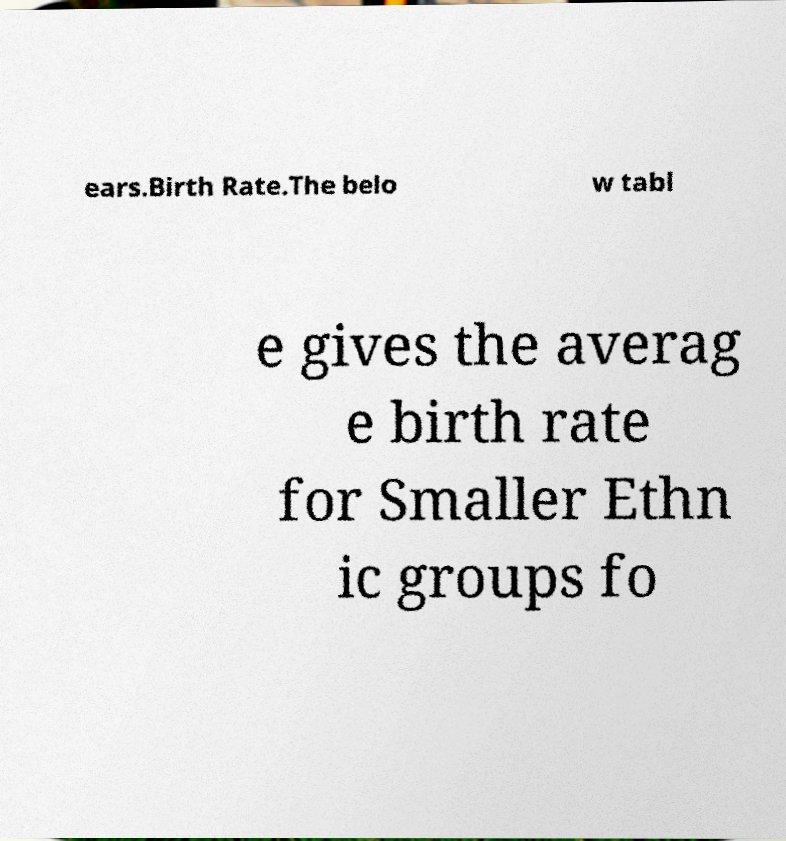Please identify and transcribe the text found in this image. ears.Birth Rate.The belo w tabl e gives the averag e birth rate for Smaller Ethn ic groups fo 